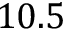<formula> <loc_0><loc_0><loc_500><loc_500>1 0 . 5</formula> 